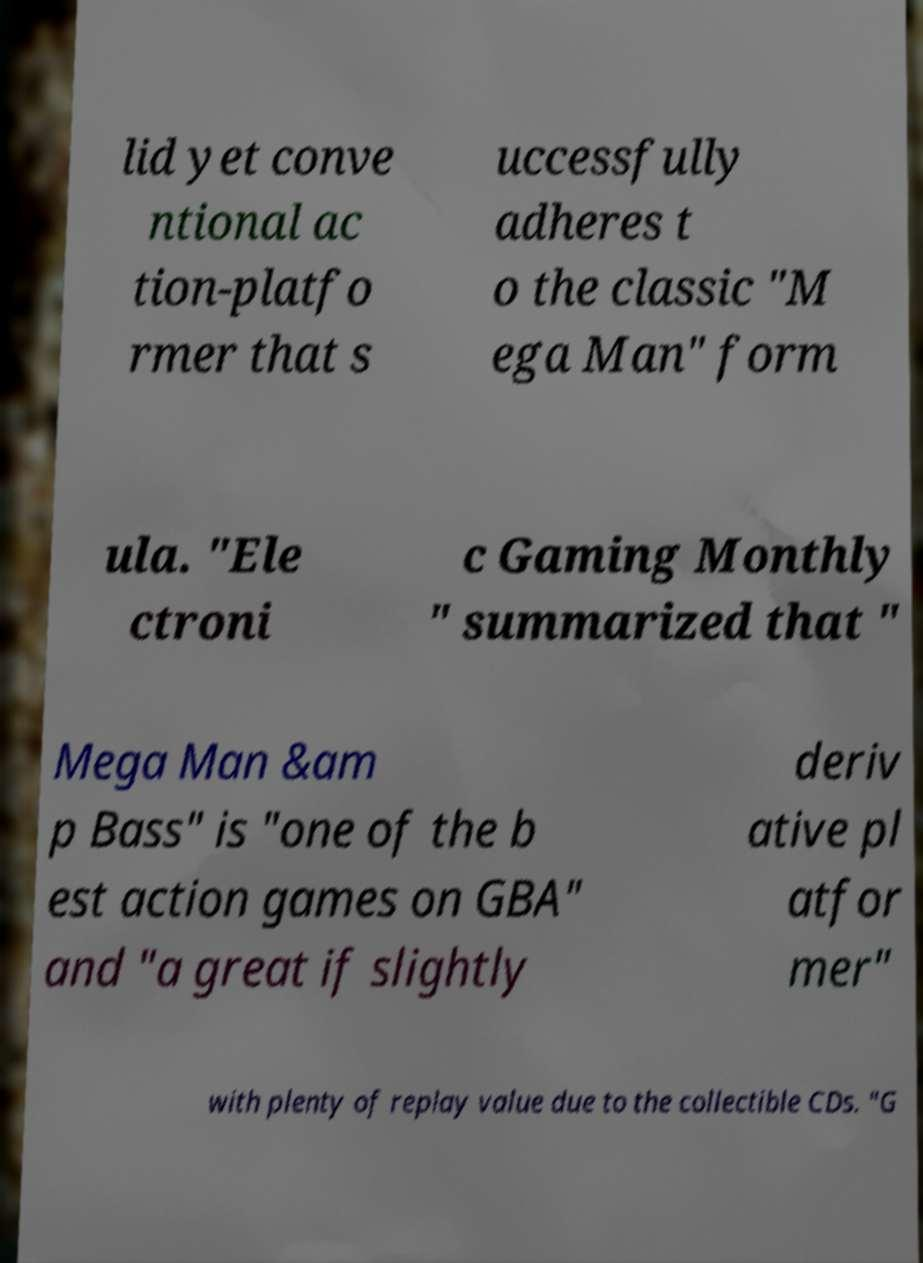Please identify and transcribe the text found in this image. lid yet conve ntional ac tion-platfo rmer that s uccessfully adheres t o the classic "M ega Man" form ula. "Ele ctroni c Gaming Monthly " summarized that " Mega Man &am p Bass" is "one of the b est action games on GBA" and "a great if slightly deriv ative pl atfor mer" with plenty of replay value due to the collectible CDs. "G 